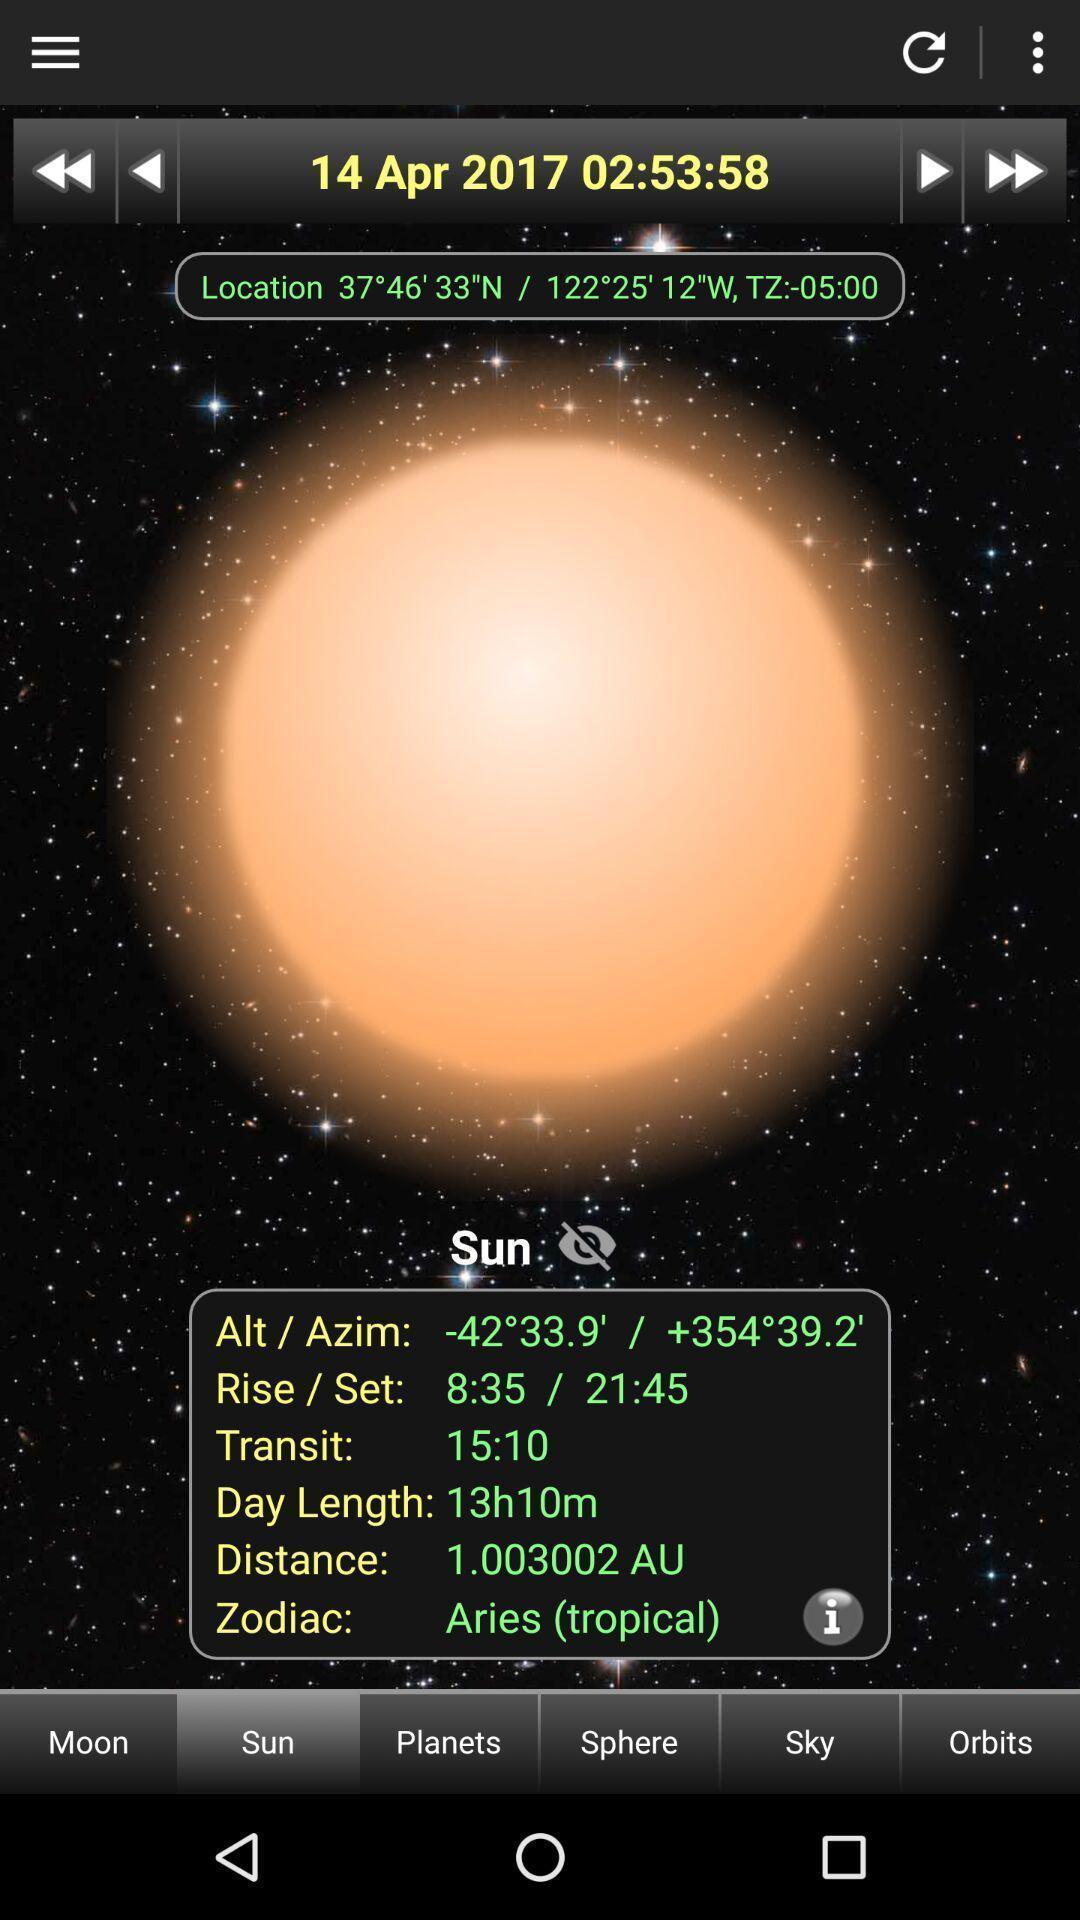Tell me what you see in this picture. Window displaying information about sun. 